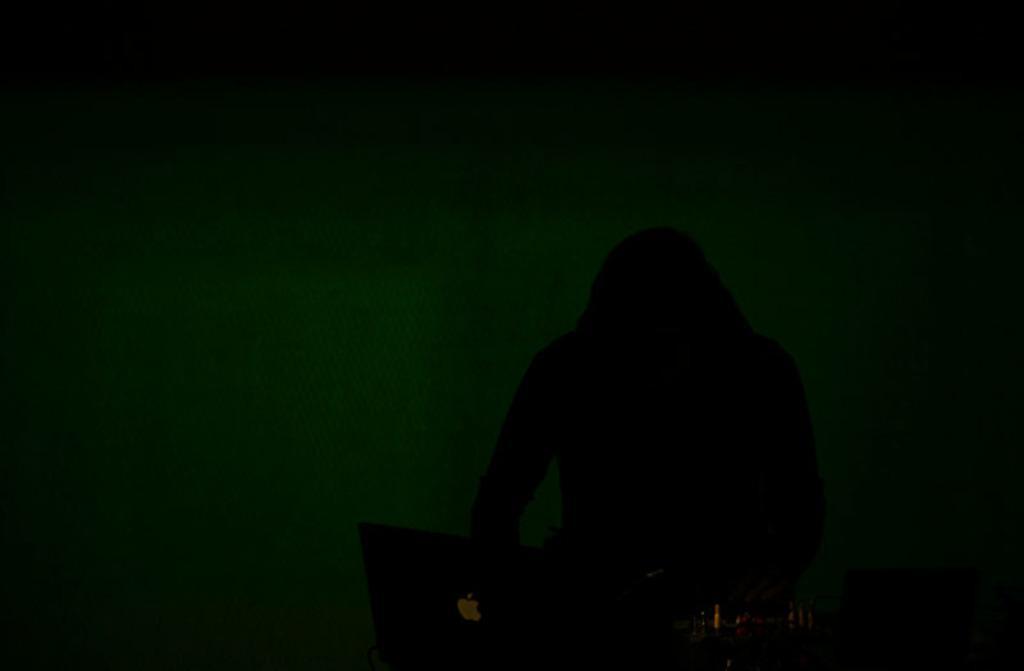Please provide a concise description of this image. In the dark image we can see a person, laptop and things. 